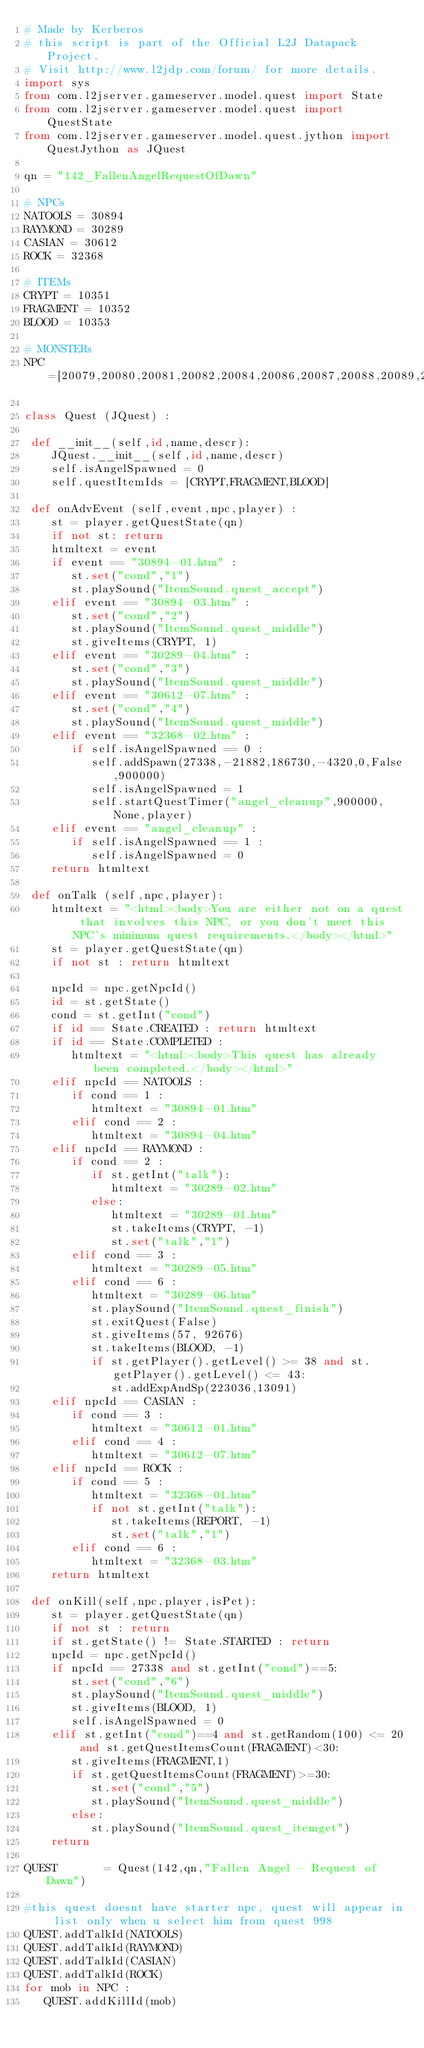<code> <loc_0><loc_0><loc_500><loc_500><_Python_># Made by Kerberos
# this script is part of the Official L2J Datapack Project.
# Visit http://www.l2jdp.com/forum/ for more details.
import sys
from com.l2jserver.gameserver.model.quest import State
from com.l2jserver.gameserver.model.quest import QuestState
from com.l2jserver.gameserver.model.quest.jython import QuestJython as JQuest

qn = "142_FallenAngelRequestOfDawn"

# NPCs
NATOOLS = 30894
RAYMOND = 30289
CASIAN = 30612
ROCK = 32368

# ITEMs
CRYPT = 10351
FRAGMENT = 10352
BLOOD = 10353

# MONSTERs
NPC=[20079,20080,20081,20082,20084,20086,20087,20088,20089,20090,27338]

class Quest (JQuest) :

 def __init__(self,id,name,descr):
    JQuest.__init__(self,id,name,descr)
    self.isAngelSpawned = 0
    self.questItemIds = [CRYPT,FRAGMENT,BLOOD]

 def onAdvEvent (self,event,npc,player) :
    st = player.getQuestState(qn)
    if not st: return
    htmltext = event
    if event == "30894-01.htm" :
       st.set("cond","1")
       st.playSound("ItemSound.quest_accept")
    elif event == "30894-03.htm" :
       st.set("cond","2")
       st.playSound("ItemSound.quest_middle")
       st.giveItems(CRYPT, 1)
    elif event == "30289-04.htm" :
       st.set("cond","3")
       st.playSound("ItemSound.quest_middle")
    elif event == "30612-07.htm" :
       st.set("cond","4")
       st.playSound("ItemSound.quest_middle")
    elif event == "32368-02.htm" :
       if self.isAngelSpawned == 0 :
          self.addSpawn(27338,-21882,186730,-4320,0,False,900000)
          self.isAngelSpawned = 1
          self.startQuestTimer("angel_cleanup",900000,None,player)
    elif event == "angel_cleanup" :
       if self.isAngelSpawned == 1 :
          self.isAngelSpawned = 0
    return htmltext

 def onTalk (self,npc,player):
    htmltext = "<html><body>You are either not on a quest that involves this NPC, or you don't meet this NPC's minimum quest requirements.</body></html>"
    st = player.getQuestState(qn)
    if not st : return htmltext

    npcId = npc.getNpcId()
    id = st.getState()
    cond = st.getInt("cond")
    if id == State.CREATED : return htmltext
    if id == State.COMPLETED :
       htmltext = "<html><body>This quest has already been completed.</body></html>"
    elif npcId == NATOOLS :
       if cond == 1 :
          htmltext = "30894-01.htm"
       elif cond == 2 :
          htmltext = "30894-04.htm"
    elif npcId == RAYMOND :
       if cond == 2 :
          if st.getInt("talk"):
             htmltext = "30289-02.htm"
          else:
             htmltext = "30289-01.htm"
             st.takeItems(CRYPT, -1)
             st.set("talk","1")
       elif cond == 3 :
          htmltext = "30289-05.htm"
       elif cond == 6 :
          htmltext = "30289-06.htm"
          st.playSound("ItemSound.quest_finish")
          st.exitQuest(False)
          st.giveItems(57, 92676)
          st.takeItems(BLOOD, -1)
          if st.getPlayer().getLevel() >= 38 and st.getPlayer().getLevel() <= 43:
             st.addExpAndSp(223036,13091)
    elif npcId == CASIAN :
       if cond == 3 :
          htmltext = "30612-01.htm"
       elif cond == 4 :
          htmltext = "30612-07.htm"
    elif npcId == ROCK :
       if cond == 5 :
          htmltext = "32368-01.htm"
          if not st.getInt("talk"):
             st.takeItems(REPORT, -1)
             st.set("talk","1")
       elif cond == 6 :
          htmltext = "32368-03.htm"
    return htmltext

 def onKill(self,npc,player,isPet):
    st = player.getQuestState(qn)
    if not st : return
    if st.getState() != State.STARTED : return
    npcId = npc.getNpcId()
    if npcId == 27338 and st.getInt("cond")==5:
       st.set("cond","6")
       st.playSound("ItemSound.quest_middle")
       st.giveItems(BLOOD, 1)
       self.isAngelSpawned = 0
    elif st.getInt("cond")==4 and st.getRandom(100) <= 20 and st.getQuestItemsCount(FRAGMENT)<30:
       st.giveItems(FRAGMENT,1)
       if st.getQuestItemsCount(FRAGMENT)>=30:
          st.set("cond","5")
          st.playSound("ItemSound.quest_middle")
       else:
          st.playSound("ItemSound.quest_itemget")
    return

QUEST       = Quest(142,qn,"Fallen Angel - Request of Dawn")

#this quest doesnt have starter npc, quest will appear in list only when u select him from quest 998
QUEST.addTalkId(NATOOLS)
QUEST.addTalkId(RAYMOND)
QUEST.addTalkId(CASIAN)
QUEST.addTalkId(ROCK)
for mob in NPC :
   QUEST.addKillId(mob)</code> 